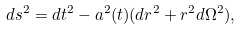Convert formula to latex. <formula><loc_0><loc_0><loc_500><loc_500>d s ^ { 2 } = d t ^ { 2 } - a ^ { 2 } ( t ) ( d r ^ { 2 } + r ^ { 2 } d \Omega ^ { 2 } ) ,</formula> 